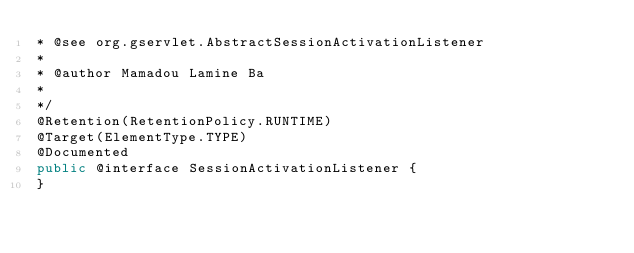Convert code to text. <code><loc_0><loc_0><loc_500><loc_500><_Java_>* @see org.gservlet.AbstractSessionActivationListener  
* 
* @author Mamadou Lamine Ba
* 
*/
@Retention(RetentionPolicy.RUNTIME)
@Target(ElementType.TYPE)
@Documented
public @interface SessionActivationListener {
}</code> 